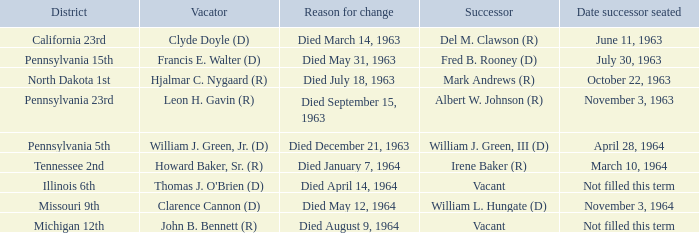What is every district for reason for change is died August 9, 1964? Michigan 12th. 